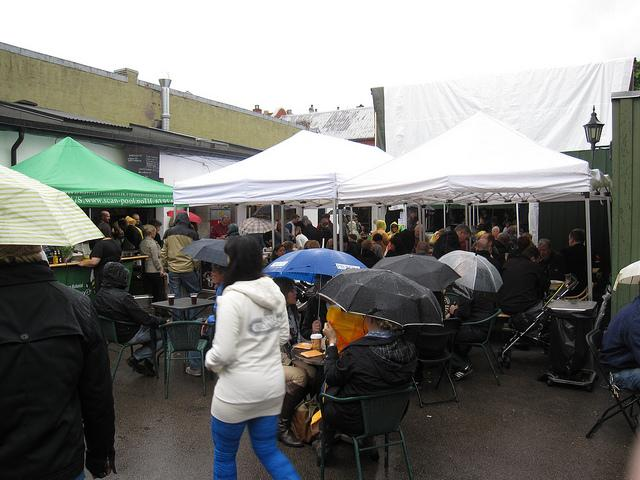Why is the outdoor area using covered gazebos?

Choices:
A) too icy
B) stay dry
C) too sunny
D) too windy stay dry 